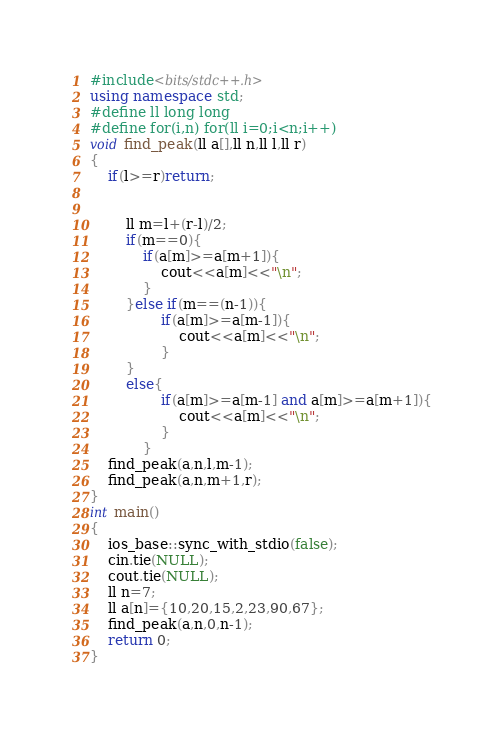Convert code to text. <code><loc_0><loc_0><loc_500><loc_500><_C++_>#include<bits/stdc++.h>
using namespace std;
#define ll long long
#define for(i,n) for(ll i=0;i<n;i++)
void find_peak(ll a[],ll n,ll l,ll r)
{
	if(l>=r)return;


		ll m=l+(r-l)/2;
		if(m==0){
			if(a[m]>=a[m+1]){
				cout<<a[m]<<"\n";
			}
		}else if(m==(n-1)){
				if(a[m]>=a[m-1]){
					cout<<a[m]<<"\n";
				}
		}
		else{
				if(a[m]>=a[m-1] and a[m]>=a[m+1]){
					cout<<a[m]<<"\n";
				}
			}
	find_peak(a,n,l,m-1);
	find_peak(a,n,m+1,r);
}
int main()
{
	ios_base::sync_with_stdio(false);
	cin.tie(NULL);
	cout.tie(NULL);
	ll n=7;
	ll a[n]={10,20,15,2,23,90,67};
	find_peak(a,n,0,n-1);
	return 0;
}
</code> 